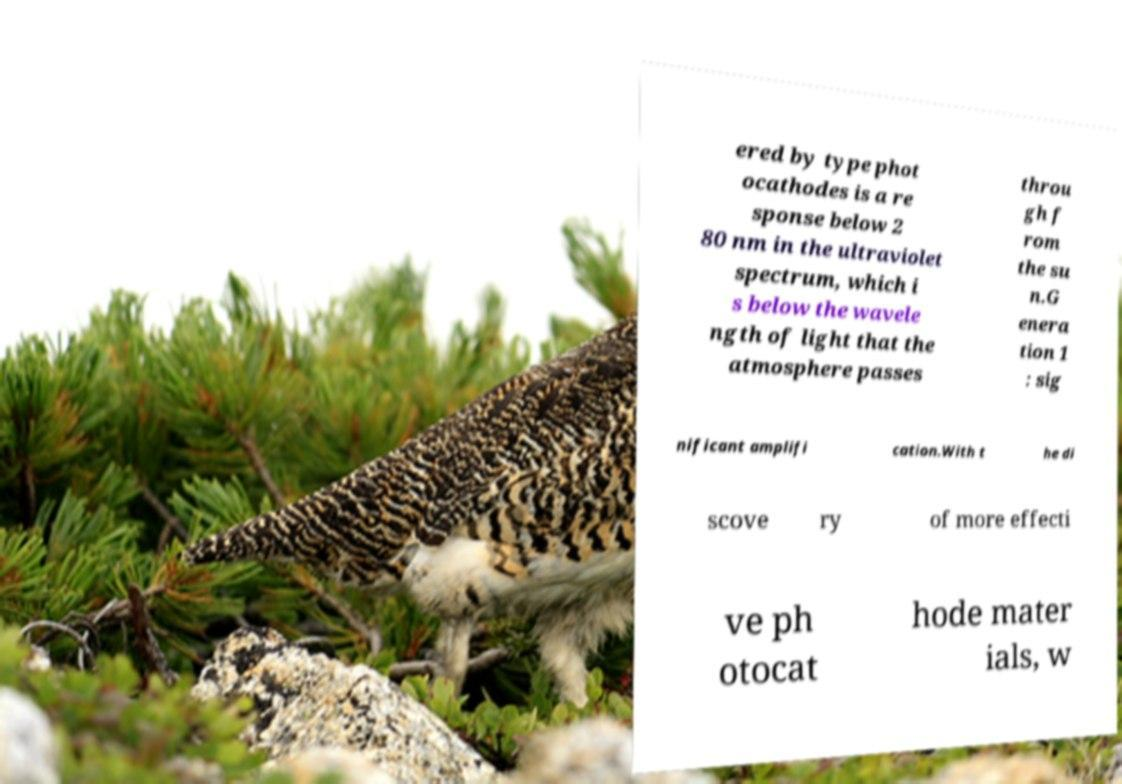Could you extract and type out the text from this image? ered by type phot ocathodes is a re sponse below 2 80 nm in the ultraviolet spectrum, which i s below the wavele ngth of light that the atmosphere passes throu gh f rom the su n.G enera tion 1 : sig nificant amplifi cation.With t he di scove ry of more effecti ve ph otocat hode mater ials, w 